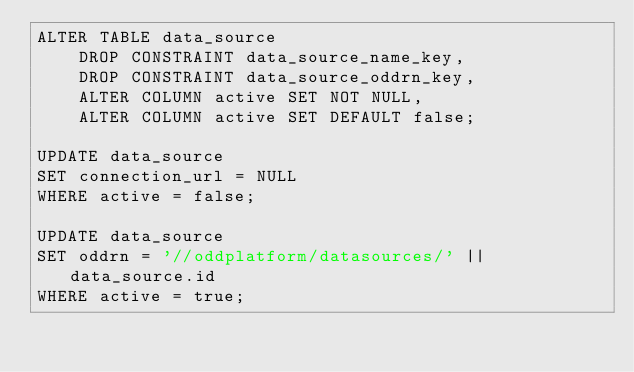Convert code to text. <code><loc_0><loc_0><loc_500><loc_500><_SQL_>ALTER TABLE data_source
    DROP CONSTRAINT data_source_name_key,
    DROP CONSTRAINT data_source_oddrn_key,
    ALTER COLUMN active SET NOT NULL,
    ALTER COLUMN active SET DEFAULT false;

UPDATE data_source
SET connection_url = NULL
WHERE active = false;

UPDATE data_source
SET oddrn = '//oddplatform/datasources/' || data_source.id
WHERE active = true;</code> 